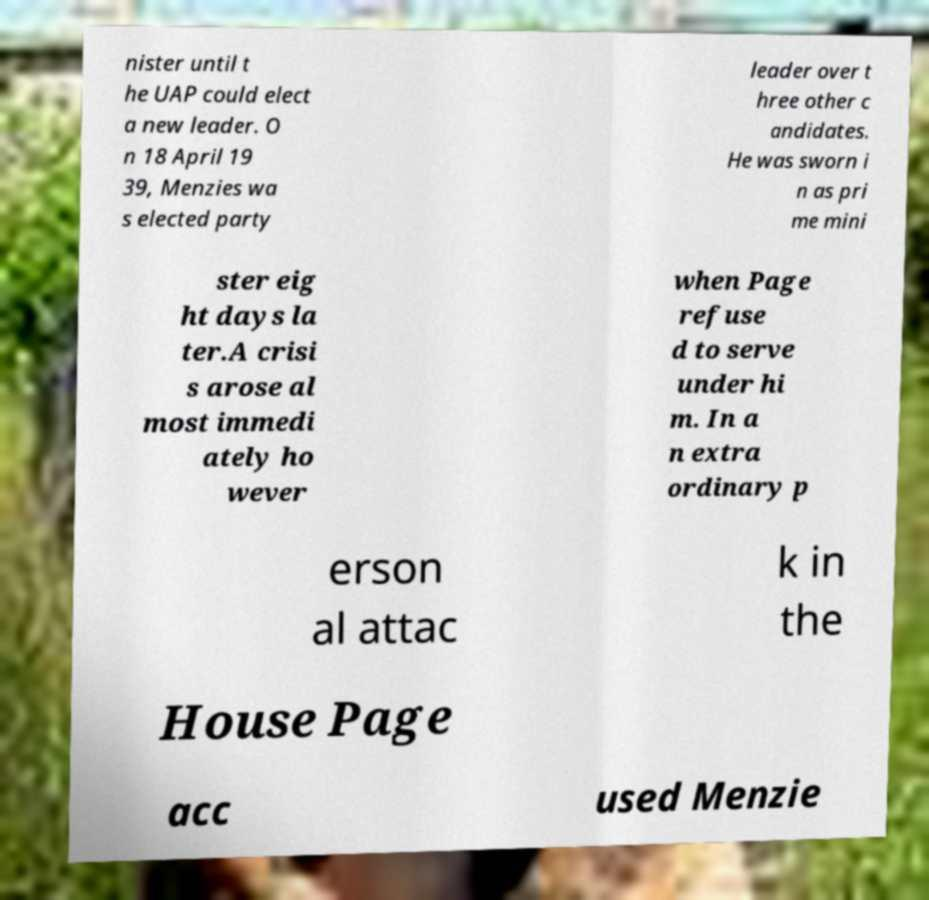There's text embedded in this image that I need extracted. Can you transcribe it verbatim? nister until t he UAP could elect a new leader. O n 18 April 19 39, Menzies wa s elected party leader over t hree other c andidates. He was sworn i n as pri me mini ster eig ht days la ter.A crisi s arose al most immedi ately ho wever when Page refuse d to serve under hi m. In a n extra ordinary p erson al attac k in the House Page acc used Menzie 